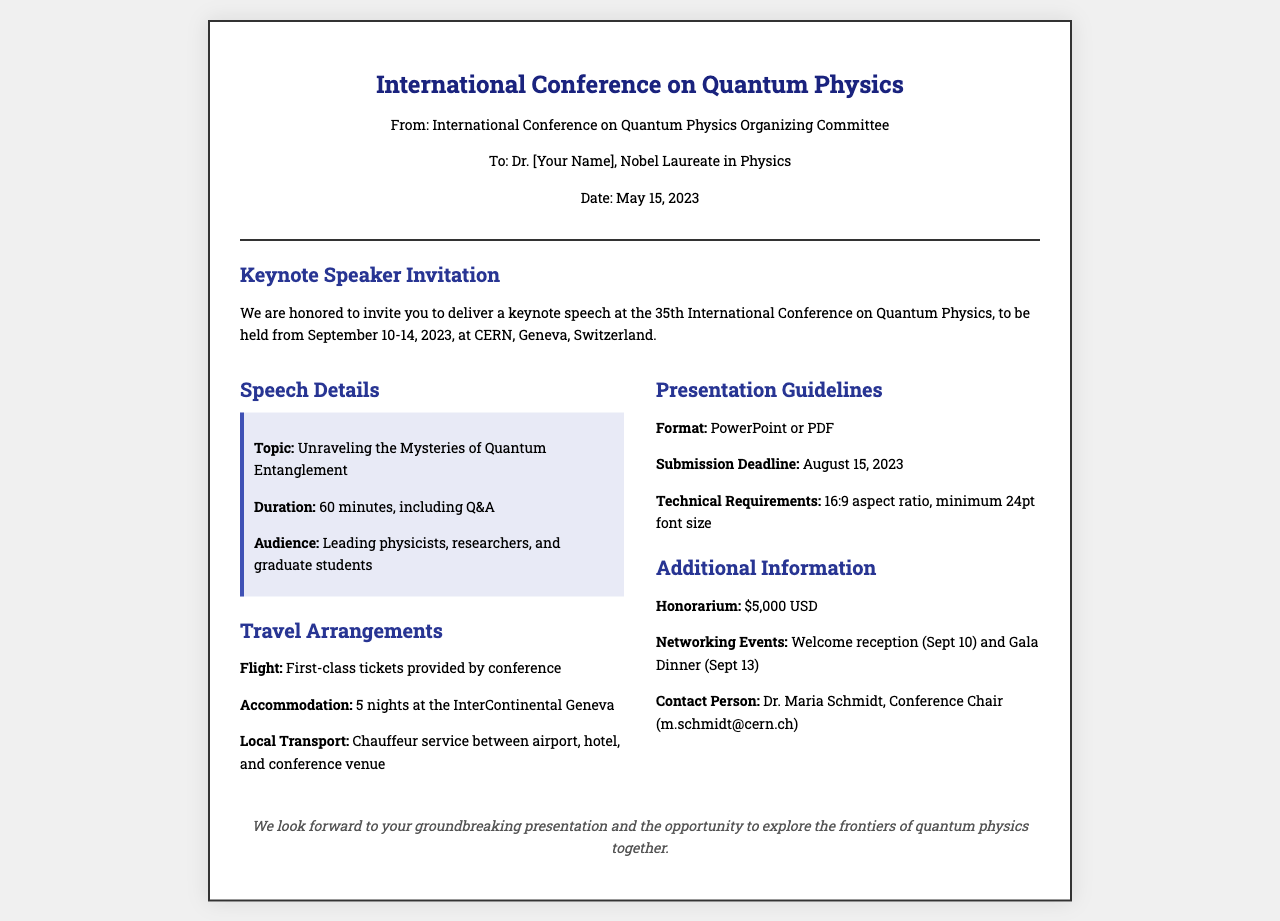What is the event name? The event name is explicitly mentioned at the top of the document as the "International Conference on Quantum Physics."
Answer: International Conference on Quantum Physics What is the keynote topic? The keynote topic is specified in the speech details section as "Unraveling the Mysteries of Quantum Entanglement."
Answer: Unraveling the Mysteries of Quantum Entanglement What is the duration of the keynote speech? The duration is stated in the details section as "60 minutes, including Q&A."
Answer: 60 minutes Where is the conference taking place? The conference location is mentioned as "CERN, Geneva, Switzerland."
Answer: CERN, Geneva, Switzerland What is the submission deadline for the presentation? The submission deadline is clearly stated in the presentation guidelines as "August 15, 2023."
Answer: August 15, 2023 How much is the honorarium? The honorarium amount is provided in the additional information section as "$5,000 USD."
Answer: $5,000 USD Who is the contact person for the conference? The contact person is listed in the additional information section as "Dr. Maria Schmidt."
Answer: Dr. Maria Schmidt What kind of travel arrangements are provided? The travel arrangements include "first-class tickets," "5 nights at the InterContinental Geneva," and "chauffeur service."
Answer: First-class tickets, 5 nights at the InterContinental Geneva, chauffeur service What are the networking events mentioned? The networking events are described as a "Welcome reception (Sept 10)" and "Gala Dinner (Sept 13)."
Answer: Welcome reception (Sept 10), Gala Dinner (Sept 13) 